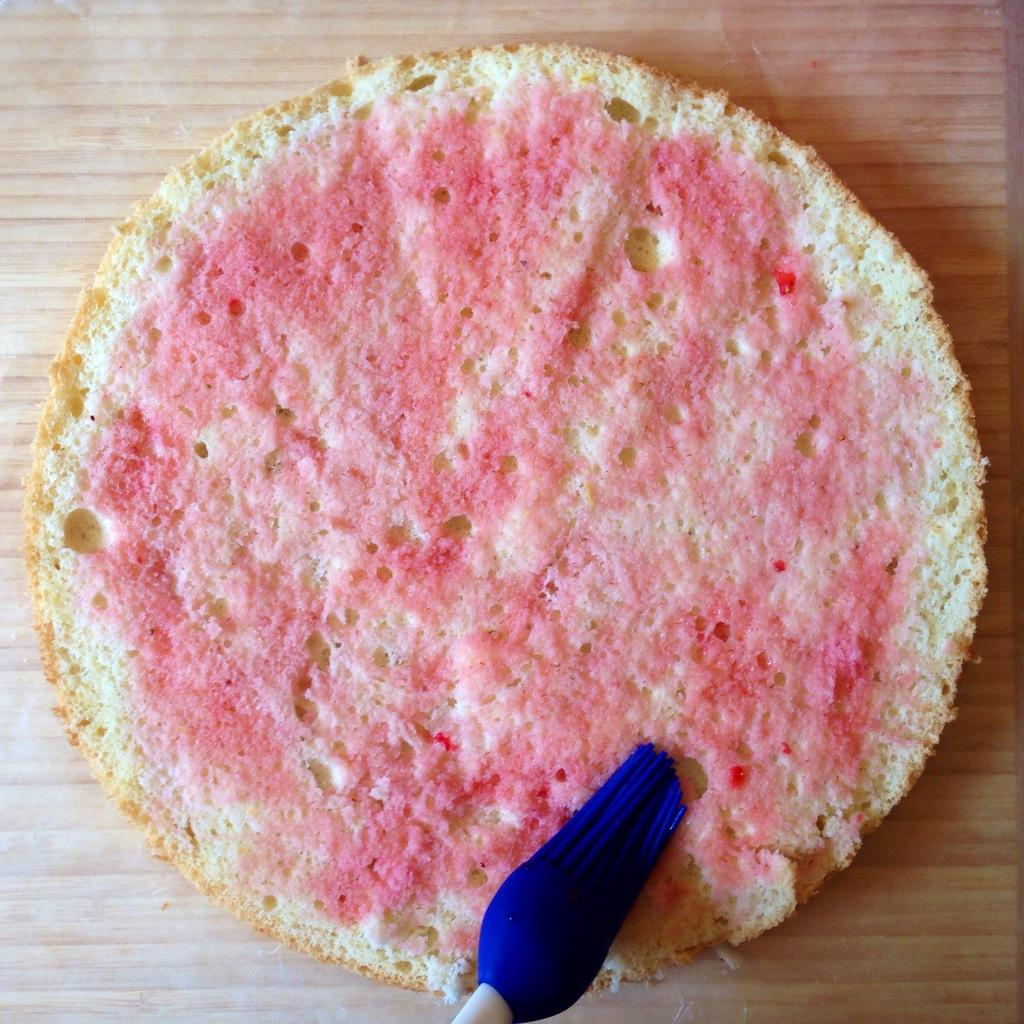What object is used for painting in the image? There is a violet color paint brush in the image. What is the paint brush placed on in the image? The paint brush is on a circular shape bread. Where is the bread with the paint brush located? The bread is on a surface. What type of pleasure can be seen in the image? There is no indication of pleasure in the image; it features a paint brush on a circular shape bread. What type of frame is present in the image? There is no frame present in the image. 